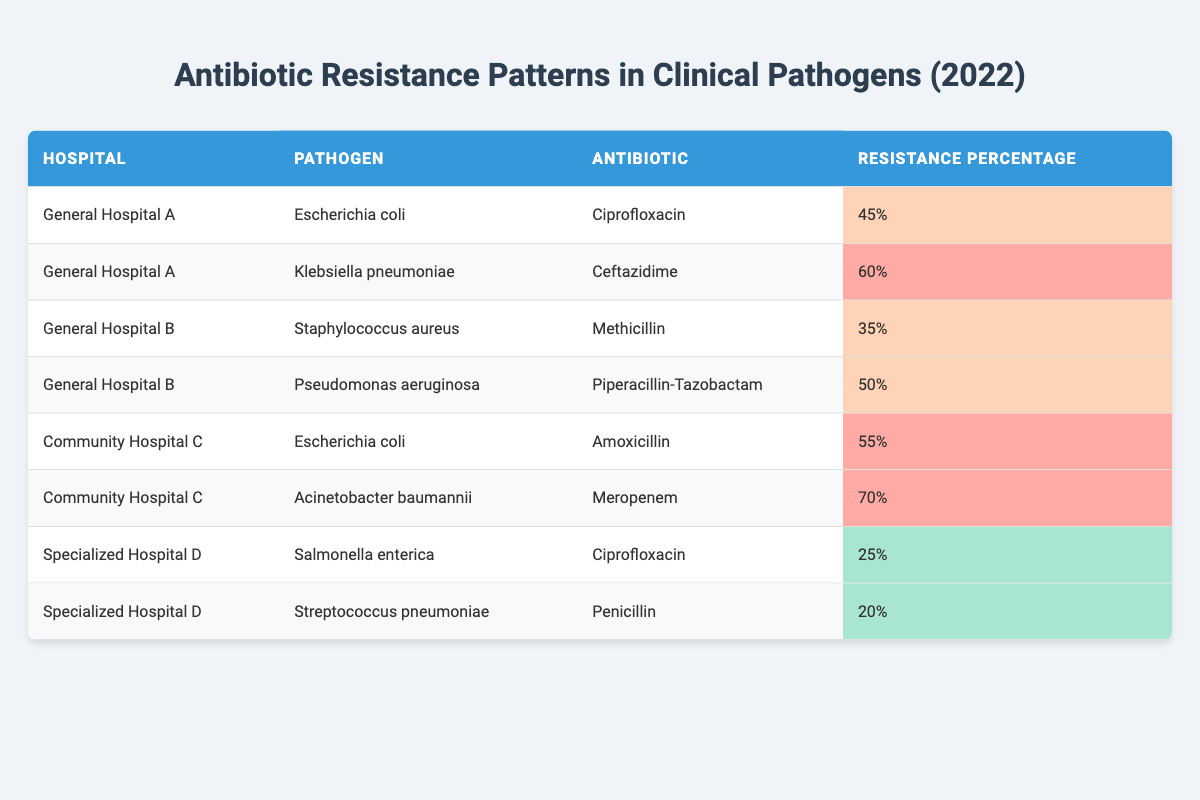What is the antibiotic resistance percentage of Klebsiella pneumoniae in General Hospital A? From the table, the specific row for Klebsiella pneumoniae in General Hospital A shows an antibiotic resistance percentage of 60%.
Answer: 60% Which hospital shows the highest antibiotic resistance percentage for Acinetobacter baumannii? The table indicates that Community Hospital C has an antibiotic resistance percentage of 70% for Acinetobacter baumannii, which is the highest value provided in the data.
Answer: Community Hospital C Is the antibiotic resistance percentage for Salmonella enterica lower than 30%? The table lists the antibiotic resistance percentage for Salmonella enterica at 25%, which is indeed lower than 30%.
Answer: Yes Calculate the average antibiotic resistance percentage for pathogens in Specialized Hospital D. The resistance percentages for Specialized Hospital D are 25% for Salmonella enterica and 20% for Streptococcus pneumoniae. Adding these together gives 25 + 20 = 45%. Dividing by the number of pathogens (2) gives an average of 45 / 2 = 22.5%.
Answer: 22.5% Among the antibiotics listed, which antibiotic has the highest recorded resistance percentage? By reviewing the resistance percentages from the table, the antibiotic with the highest resistance percentage is Meropenem, at 70% in Community Hospital C.
Answer: Meropenem How many pathogens show an antibiotic resistance percentage above 50%? In the table, the pathogens with resistance percentages above 50% are Acinetobacter baumannii (70%) and Klebsiella pneumoniae (60%) from two separate hospitals, making a total of two pathogens.
Answer: 2 Is Escherichia coli recorded in both General Hospital A and Community Hospital C? Yes, Escherichia coli appears in General Hospital A with a resistance percentage of 45% and in Community Hospital C with a resistance percentage of 55%.
Answer: Yes What is the difference in antibiotic resistance percentages between Pseudomonas aeruginosa in General Hospital B and Escherichia coli in Community Hospital C? Pseudomonas aeruginosa has a resistance percentage of 50%, while Escherichia coli in Community Hospital C has a resistance percentage of 55%. The difference can be calculated as 55 - 50 = 5%.
Answer: 5% 